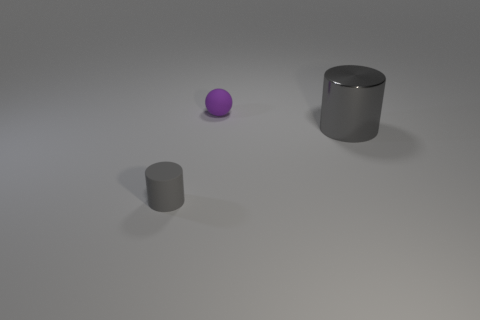Add 1 small gray matte cylinders. How many objects exist? 4 Subtract all balls. How many objects are left? 2 Subtract 0 blue balls. How many objects are left? 3 Subtract all tiny red rubber cubes. Subtract all tiny purple matte things. How many objects are left? 2 Add 3 small purple balls. How many small purple balls are left? 4 Add 3 matte cylinders. How many matte cylinders exist? 4 